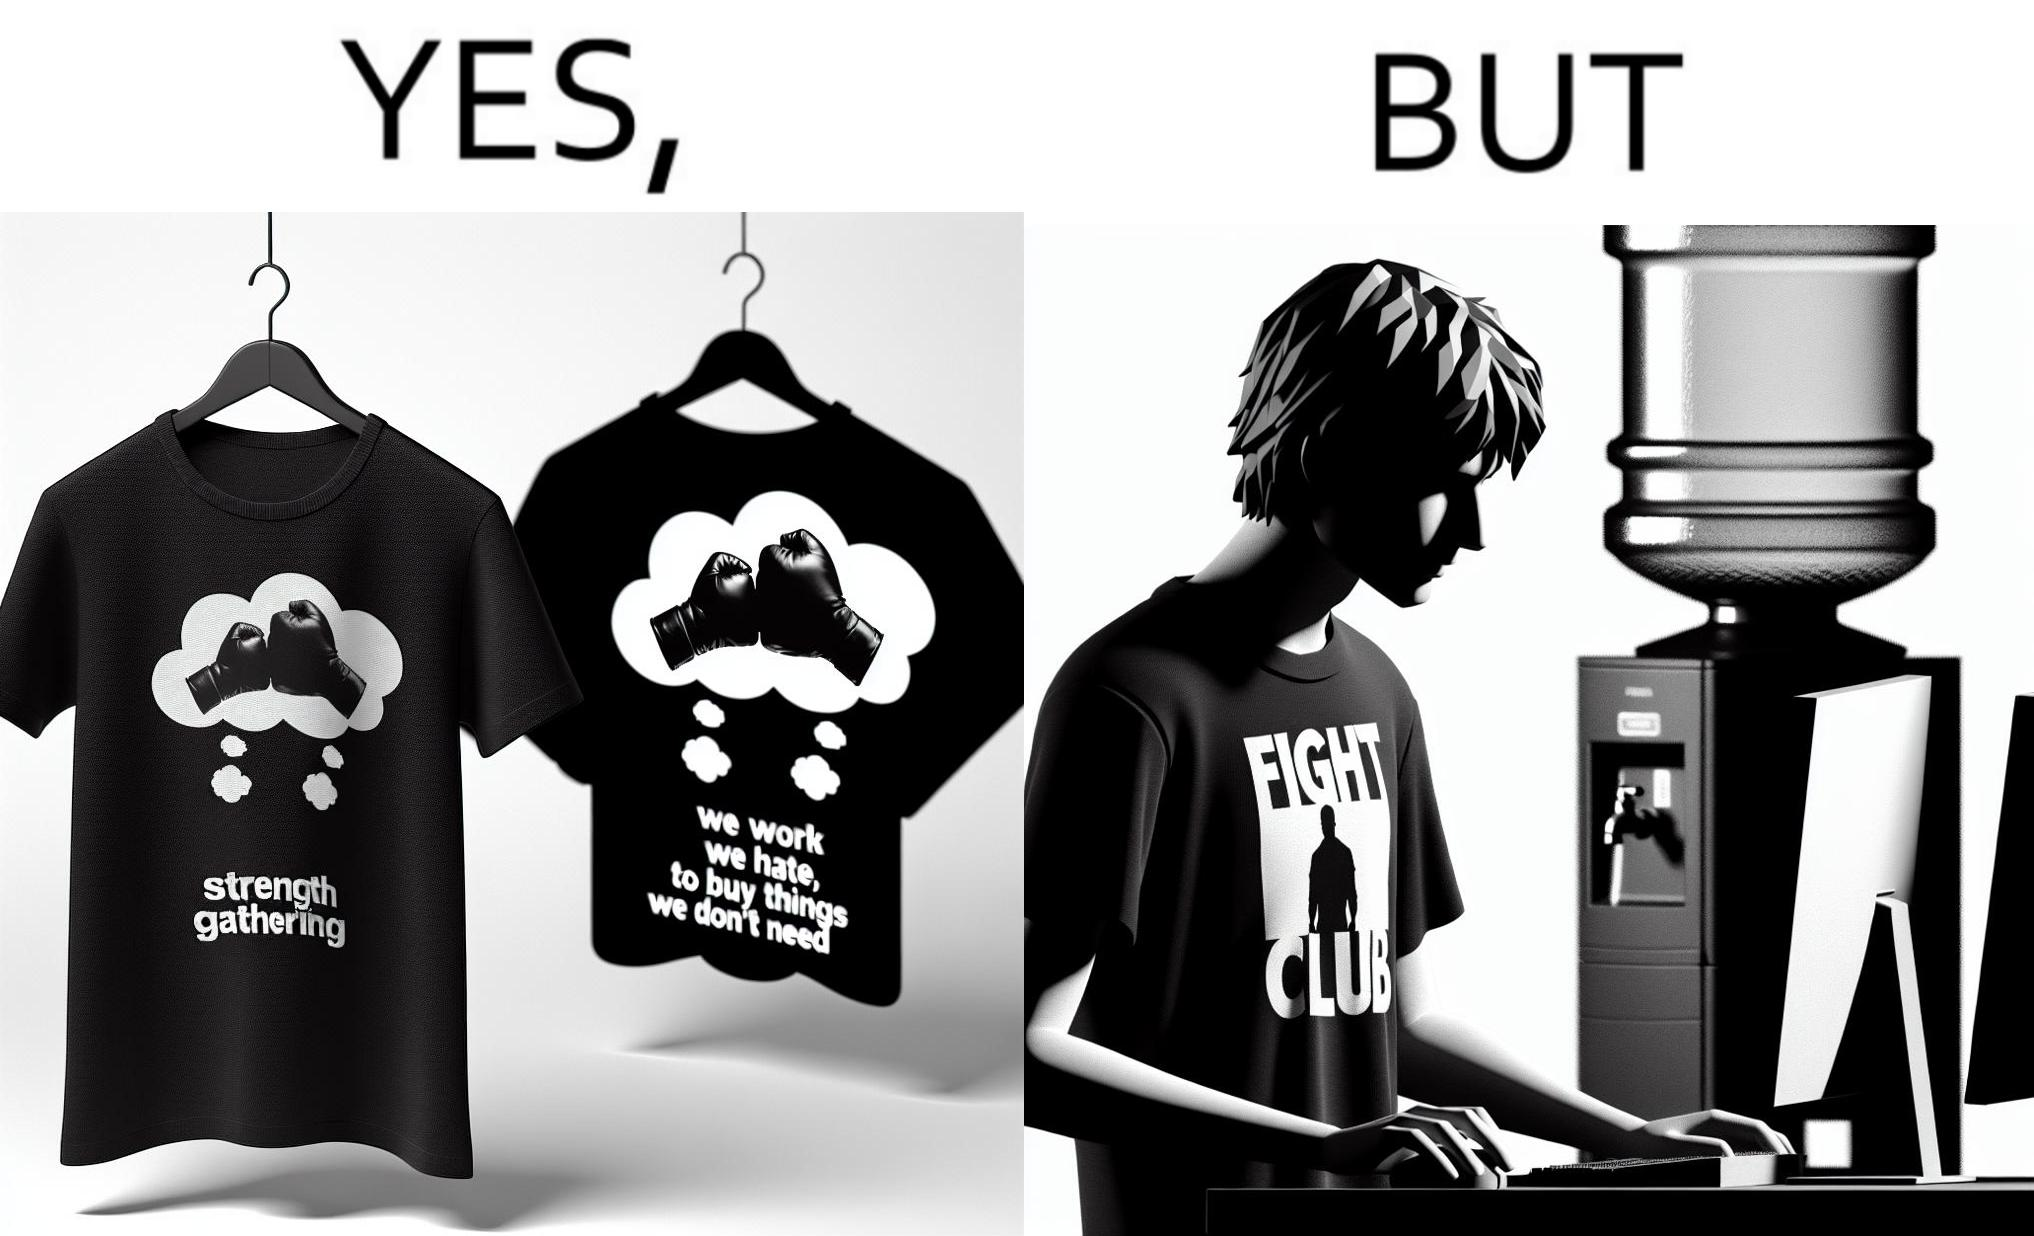Describe what you see in this image. The image is ironical, as the t-shirt says "We work jobs we hate, to buy sh*t we don't need", which is a rebellious message against the construct of office jobs. However, the person wearing the t-shirt seems to be working in an office environment. Also, the t-shirt might have been bought using the money earned via the very same job. 